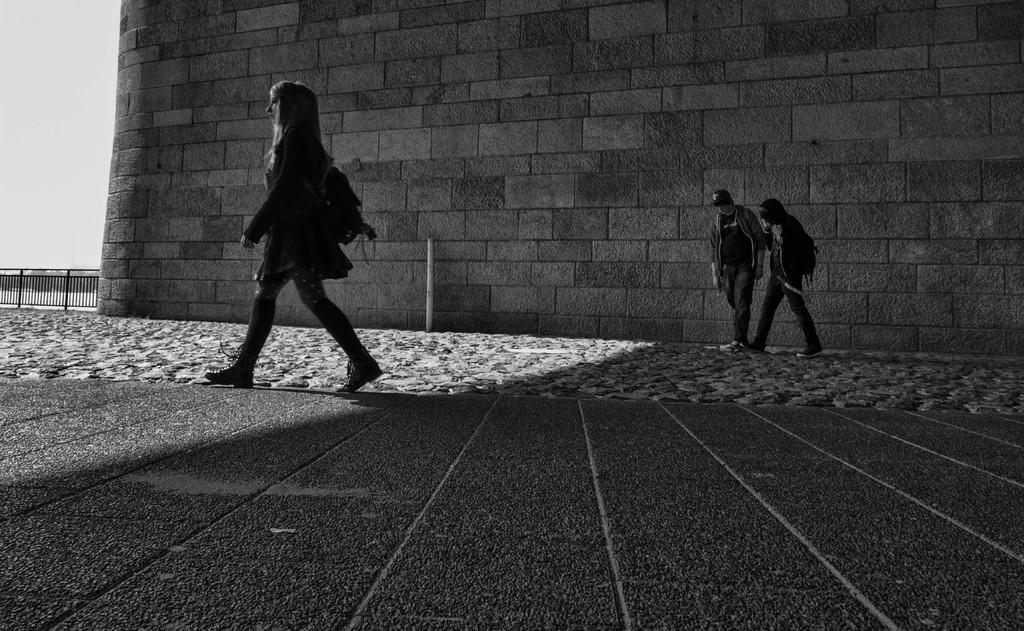What can be seen in the image? There are people in the image. What is the surface that the people are standing on? The ground is visible in the image. What structure can be seen in the image? There is a pole in the image. What type of barrier is present in the image? There is fencing in the image. What architectural feature is visible in the image? There is a wall in the image. What part of the natural environment is visible in the image? The sky is visible in the image. What type of machine can be heard in the image? There is no machine present in the image, and therefore no sound can be heard. How does the wall in the image cause the people to feel? The image does not provide information about the people's emotions or how the wall affects them. 